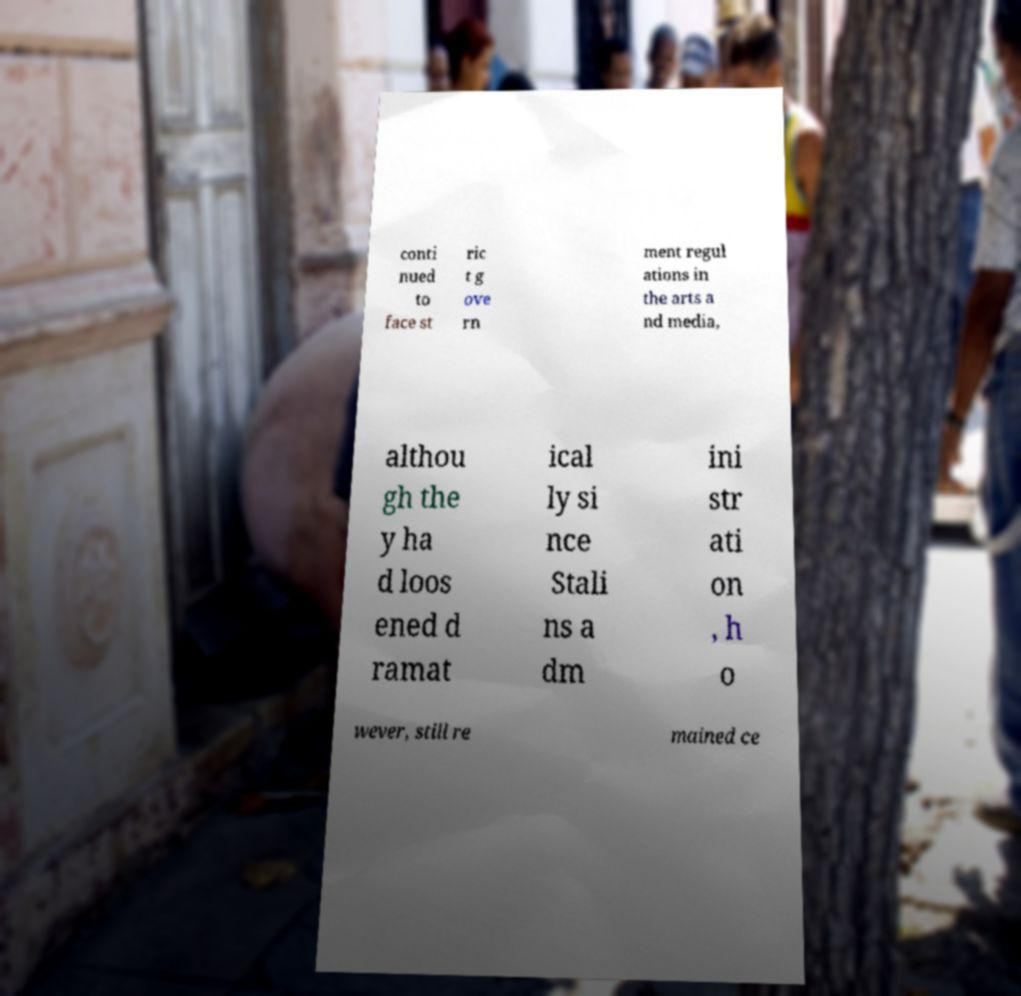There's text embedded in this image that I need extracted. Can you transcribe it verbatim? conti nued to face st ric t g ove rn ment regul ations in the arts a nd media, althou gh the y ha d loos ened d ramat ical ly si nce Stali ns a dm ini str ati on , h o wever, still re mained ce 